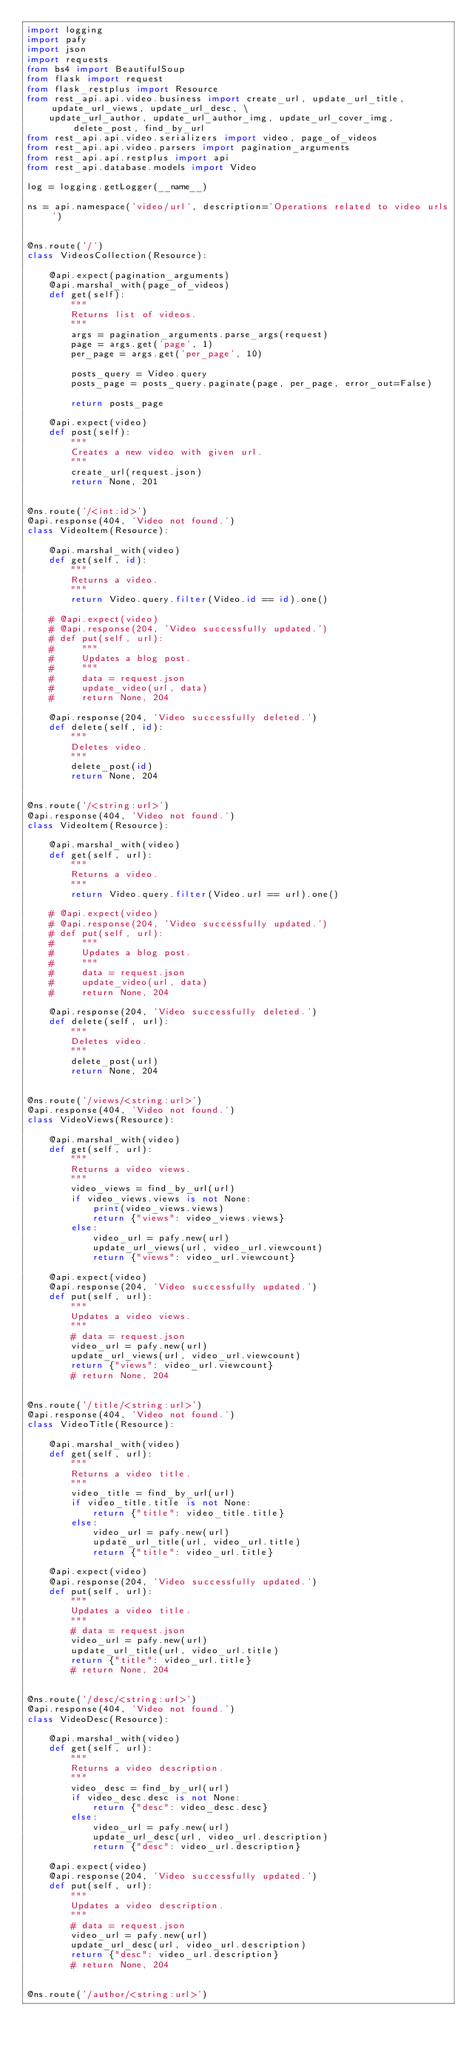Convert code to text. <code><loc_0><loc_0><loc_500><loc_500><_Python_>import logging
import pafy
import json
import requests
from bs4 import BeautifulSoup
from flask import request
from flask_restplus import Resource
from rest_api.api.video.business import create_url, update_url_title, update_url_views, update_url_desc, \
    update_url_author, update_url_author_img, update_url_cover_img, delete_post, find_by_url
from rest_api.api.video.serializers import video, page_of_videos
from rest_api.api.video.parsers import pagination_arguments
from rest_api.api.restplus import api
from rest_api.database.models import Video

log = logging.getLogger(__name__)

ns = api.namespace('video/url', description='Operations related to video urls')


@ns.route('/')
class VideosCollection(Resource):

    @api.expect(pagination_arguments)
    @api.marshal_with(page_of_videos)
    def get(self):
        """
        Returns list of videos.
        """
        args = pagination_arguments.parse_args(request)
        page = args.get('page', 1)
        per_page = args.get('per_page', 10)

        posts_query = Video.query
        posts_page = posts_query.paginate(page, per_page, error_out=False)

        return posts_page

    @api.expect(video)
    def post(self):
        """
        Creates a new video with given url.
        """
        create_url(request.json)
        return None, 201


@ns.route('/<int:id>')
@api.response(404, 'Video not found.')
class VideoItem(Resource):

    @api.marshal_with(video)
    def get(self, id):
        """
        Returns a video.
        """
        return Video.query.filter(Video.id == id).one()

    # @api.expect(video)
    # @api.response(204, 'Video successfully updated.')
    # def put(self, url):
    #     """
    #     Updates a blog post.
    #     """
    #     data = request.json
    #     update_video(url, data)
    #     return None, 204

    @api.response(204, 'Video successfully deleted.')
    def delete(self, id):
        """
        Deletes video.
        """
        delete_post(id)
        return None, 204


@ns.route('/<string:url>')
@api.response(404, 'Video not found.')
class VideoItem(Resource):

    @api.marshal_with(video)
    def get(self, url):
        """
        Returns a video.
        """
        return Video.query.filter(Video.url == url).one()

    # @api.expect(video)
    # @api.response(204, 'Video successfully updated.')
    # def put(self, url):
    #     """
    #     Updates a blog post.
    #     """
    #     data = request.json
    #     update_video(url, data)
    #     return None, 204

    @api.response(204, 'Video successfully deleted.')
    def delete(self, url):
        """
        Deletes video.
        """
        delete_post(url)
        return None, 204


@ns.route('/views/<string:url>')
@api.response(404, 'Video not found.')
class VideoViews(Resource):

    @api.marshal_with(video)
    def get(self, url):
        """
        Returns a video views.
        """
        video_views = find_by_url(url)
        if video_views.views is not None:
            print(video_views.views)
            return {"views": video_views.views}
        else:
            video_url = pafy.new(url)
            update_url_views(url, video_url.viewcount)
            return {"views": video_url.viewcount}

    @api.expect(video)
    @api.response(204, 'Video successfully updated.')
    def put(self, url):
        """
        Updates a video views.
        """
        # data = request.json
        video_url = pafy.new(url)
        update_url_views(url, video_url.viewcount)
        return {"views": video_url.viewcount}
        # return None, 204


@ns.route('/title/<string:url>')
@api.response(404, 'Video not found.')
class VideoTitle(Resource):

    @api.marshal_with(video)
    def get(self, url):
        """
        Returns a video title.
        """
        video_title = find_by_url(url)
        if video_title.title is not None:
            return {"title": video_title.title}
        else:
            video_url = pafy.new(url)
            update_url_title(url, video_url.title)
            return {"title": video_url.title}

    @api.expect(video)
    @api.response(204, 'Video successfully updated.')
    def put(self, url):
        """
        Updates a video title.
        """
        # data = request.json
        video_url = pafy.new(url)
        update_url_title(url, video_url.title)
        return {"title": video_url.title}
        # return None, 204


@ns.route('/desc/<string:url>')
@api.response(404, 'Video not found.')
class VideoDesc(Resource):

    @api.marshal_with(video)
    def get(self, url):
        """
        Returns a video description.
        """
        video_desc = find_by_url(url)
        if video_desc.desc is not None:
            return {"desc": video_desc.desc}
        else:
            video_url = pafy.new(url)
            update_url_desc(url, video_url.description)
            return {"desc": video_url.description}

    @api.expect(video)
    @api.response(204, 'Video successfully updated.')
    def put(self, url):
        """
        Updates a video description.
        """
        # data = request.json
        video_url = pafy.new(url)
        update_url_desc(url, video_url.description)
        return {"desc": video_url.description}
        # return None, 204


@ns.route('/author/<string:url>')</code> 